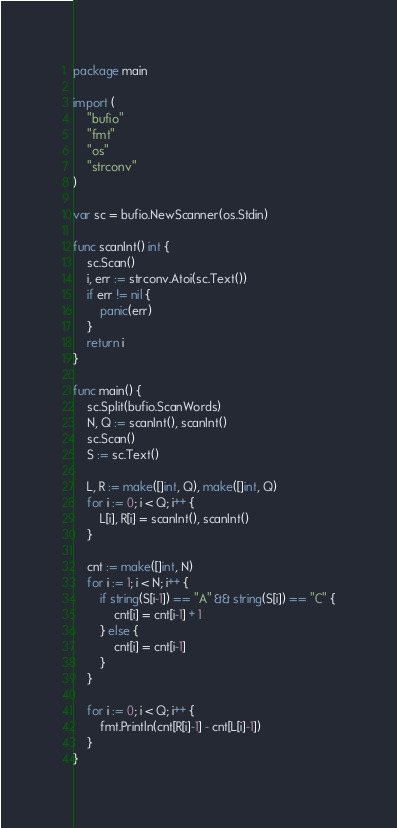Convert code to text. <code><loc_0><loc_0><loc_500><loc_500><_Go_>package main

import (
	"bufio"
	"fmt"
	"os"
	"strconv"
)

var sc = bufio.NewScanner(os.Stdin)

func scanInt() int {
	sc.Scan()
	i, err := strconv.Atoi(sc.Text())
	if err != nil {
		panic(err)
	}
	return i
}

func main() {
	sc.Split(bufio.ScanWords)
	N, Q := scanInt(), scanInt()
	sc.Scan()
	S := sc.Text()

	L, R := make([]int, Q), make([]int, Q)
	for i := 0; i < Q; i++ {
		L[i], R[i] = scanInt(), scanInt()
	}

	cnt := make([]int, N)
	for i := 1; i < N; i++ {
		if string(S[i-1]) == "A" && string(S[i]) == "C" {
			cnt[i] = cnt[i-1] + 1
		} else {
			cnt[i] = cnt[i-1]
		}
	}

	for i := 0; i < Q; i++ {
		fmt.Println(cnt[R[i]-1] - cnt[L[i]-1])
	}
}
</code> 